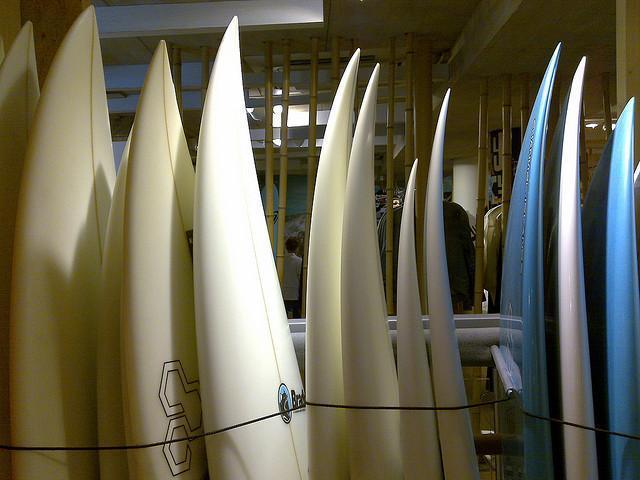How many surfboards are there?
Give a very brief answer. 11. How many surfboards can be seen?
Give a very brief answer. 12. 